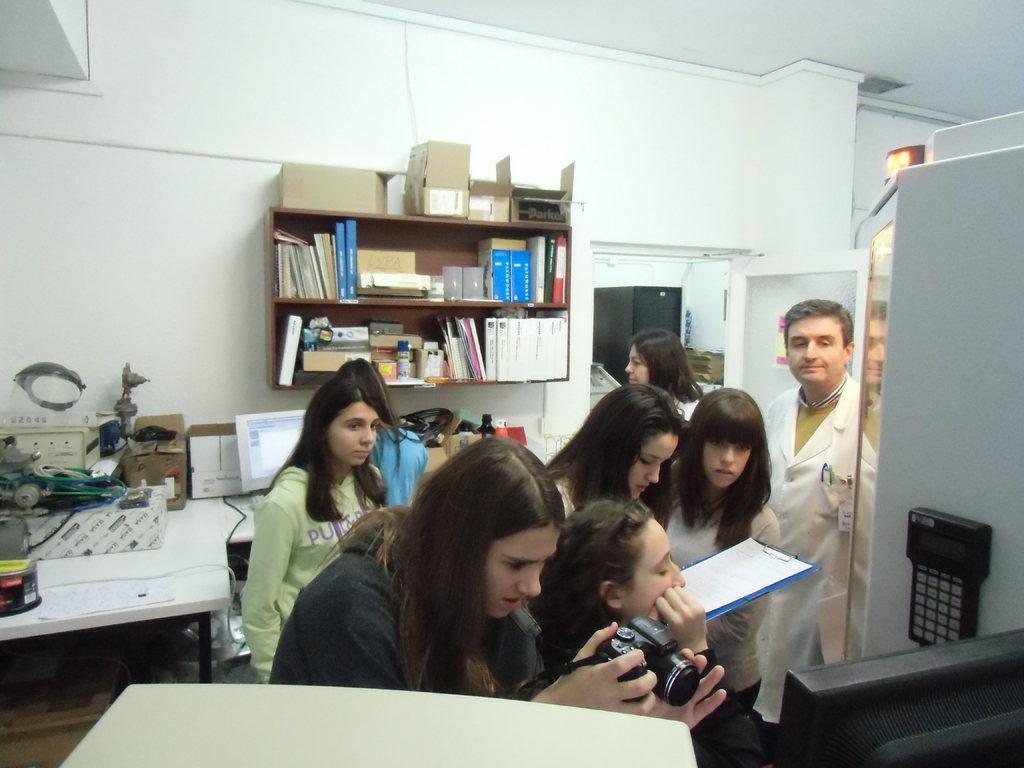Could you give a brief overview of what you see in this image? There is a woman in black color t-shirt holding a camera and capturing something in front of a monitor and a white color object. In the background, there are persons standing on the floor, there is a table on which there is a monitor and other objects, there are files and other objects arranged on the shelves and there is white wall. 